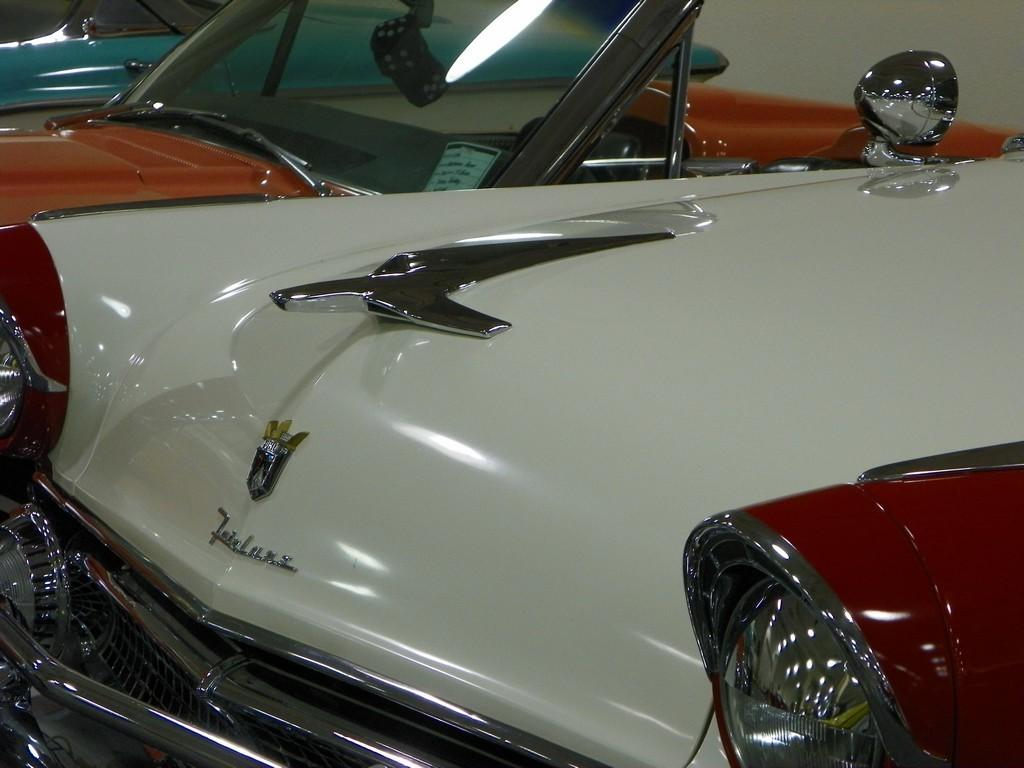What types of objects are present in the image? There are vehicles in the image. What distinguishing features do the vehicles have? The vehicles have logos and headlights. Can you see a receipt for the vehicles in the image? There is no receipt present in the image; it only shows vehicles with logos and headlights. 